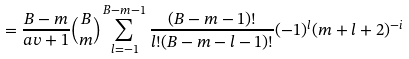<formula> <loc_0><loc_0><loc_500><loc_500>= \frac { B - m } { \real a v + 1 } { B \choose m } \sum _ { l = - 1 } ^ { B - m - 1 } \frac { ( B - m - 1 ) ! } { l ! ( B - m - l - 1 ) ! } ( - 1 ) ^ { l } ( m + l + 2 ) ^ { - i }</formula> 